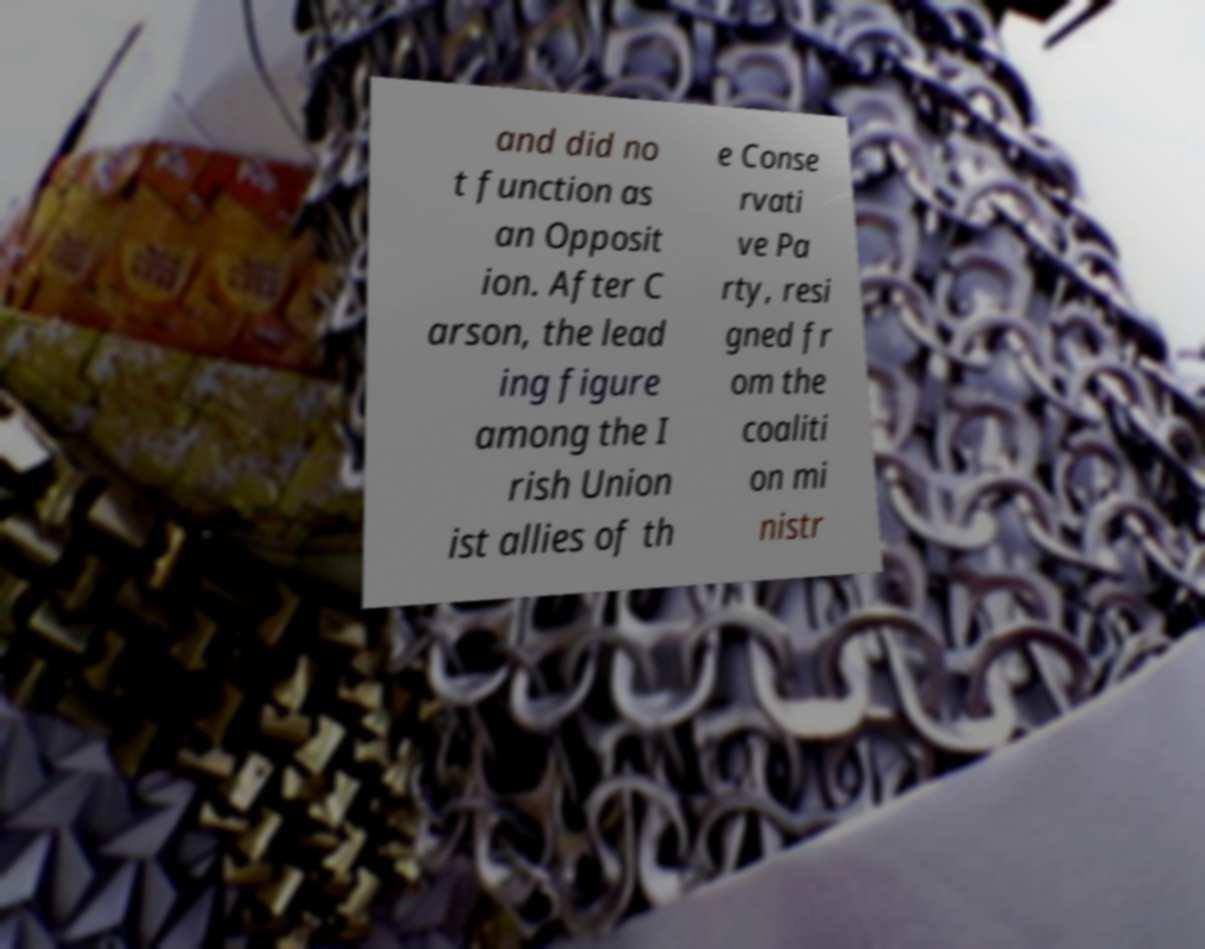Can you read and provide the text displayed in the image?This photo seems to have some interesting text. Can you extract and type it out for me? and did no t function as an Opposit ion. After C arson, the lead ing figure among the I rish Union ist allies of th e Conse rvati ve Pa rty, resi gned fr om the coaliti on mi nistr 